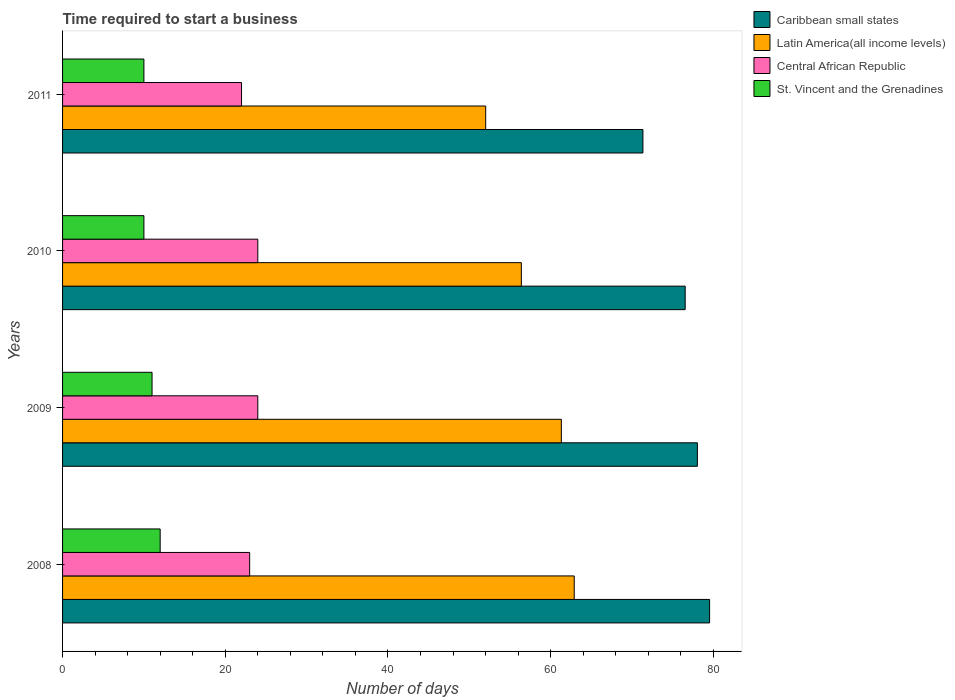How many groups of bars are there?
Your response must be concise. 4. In how many cases, is the number of bars for a given year not equal to the number of legend labels?
Make the answer very short. 0. In which year was the number of days required to start a business in Latin America(all income levels) maximum?
Your answer should be very brief. 2008. What is the total number of days required to start a business in Latin America(all income levels) in the graph?
Your answer should be very brief. 232.63. What is the difference between the number of days required to start a business in St. Vincent and the Grenadines in 2011 and the number of days required to start a business in Latin America(all income levels) in 2008?
Give a very brief answer. -52.9. What is the average number of days required to start a business in St. Vincent and the Grenadines per year?
Provide a short and direct response. 10.75. In the year 2009, what is the difference between the number of days required to start a business in Latin America(all income levels) and number of days required to start a business in Central African Republic?
Provide a short and direct response. 37.32. What is the ratio of the number of days required to start a business in Caribbean small states in 2010 to that in 2011?
Your answer should be compact. 1.07. Is the number of days required to start a business in St. Vincent and the Grenadines in 2009 less than that in 2010?
Provide a succinct answer. No. What is the difference between the highest and the lowest number of days required to start a business in Caribbean small states?
Provide a succinct answer. 8.2. In how many years, is the number of days required to start a business in Latin America(all income levels) greater than the average number of days required to start a business in Latin America(all income levels) taken over all years?
Provide a short and direct response. 2. Is the sum of the number of days required to start a business in Central African Republic in 2009 and 2011 greater than the maximum number of days required to start a business in Caribbean small states across all years?
Ensure brevity in your answer.  No. What does the 4th bar from the top in 2008 represents?
Your answer should be very brief. Caribbean small states. What does the 2nd bar from the bottom in 2008 represents?
Your answer should be very brief. Latin America(all income levels). How many bars are there?
Provide a short and direct response. 16. How many years are there in the graph?
Offer a very short reply. 4. What is the title of the graph?
Give a very brief answer. Time required to start a business. What is the label or title of the X-axis?
Make the answer very short. Number of days. What is the Number of days of Caribbean small states in 2008?
Provide a succinct answer. 79.54. What is the Number of days of Latin America(all income levels) in 2008?
Offer a very short reply. 62.9. What is the Number of days of Caribbean small states in 2009?
Your answer should be very brief. 78.04. What is the Number of days in Latin America(all income levels) in 2009?
Provide a short and direct response. 61.32. What is the Number of days of Caribbean small states in 2010?
Give a very brief answer. 76.54. What is the Number of days in Latin America(all income levels) in 2010?
Provide a succinct answer. 56.4. What is the Number of days of Central African Republic in 2010?
Keep it short and to the point. 24. What is the Number of days of Caribbean small states in 2011?
Give a very brief answer. 71.35. What is the Number of days of Latin America(all income levels) in 2011?
Your answer should be compact. 52.02. Across all years, what is the maximum Number of days of Caribbean small states?
Your response must be concise. 79.54. Across all years, what is the maximum Number of days of Latin America(all income levels)?
Provide a short and direct response. 62.9. Across all years, what is the minimum Number of days of Caribbean small states?
Provide a short and direct response. 71.35. Across all years, what is the minimum Number of days in Latin America(all income levels)?
Offer a very short reply. 52.02. Across all years, what is the minimum Number of days of Central African Republic?
Provide a succinct answer. 22. What is the total Number of days in Caribbean small states in the graph?
Keep it short and to the point. 305.47. What is the total Number of days of Latin America(all income levels) in the graph?
Make the answer very short. 232.63. What is the total Number of days of Central African Republic in the graph?
Provide a succinct answer. 93. What is the total Number of days of St. Vincent and the Grenadines in the graph?
Offer a very short reply. 43. What is the difference between the Number of days of Latin America(all income levels) in 2008 and that in 2009?
Your answer should be very brief. 1.58. What is the difference between the Number of days of Central African Republic in 2008 and that in 2009?
Keep it short and to the point. -1. What is the difference between the Number of days of St. Vincent and the Grenadines in 2008 and that in 2009?
Your answer should be compact. 1. What is the difference between the Number of days of Caribbean small states in 2008 and that in 2010?
Ensure brevity in your answer.  3. What is the difference between the Number of days in Latin America(all income levels) in 2008 and that in 2010?
Offer a terse response. 6.5. What is the difference between the Number of days of St. Vincent and the Grenadines in 2008 and that in 2010?
Make the answer very short. 2. What is the difference between the Number of days of Caribbean small states in 2008 and that in 2011?
Provide a succinct answer. 8.2. What is the difference between the Number of days of Latin America(all income levels) in 2008 and that in 2011?
Ensure brevity in your answer.  10.88. What is the difference between the Number of days of Latin America(all income levels) in 2009 and that in 2010?
Your response must be concise. 4.92. What is the difference between the Number of days in Central African Republic in 2009 and that in 2010?
Your response must be concise. 0. What is the difference between the Number of days in St. Vincent and the Grenadines in 2009 and that in 2010?
Your response must be concise. 1. What is the difference between the Number of days in Caribbean small states in 2009 and that in 2011?
Make the answer very short. 6.7. What is the difference between the Number of days in Latin America(all income levels) in 2009 and that in 2011?
Your response must be concise. 9.3. What is the difference between the Number of days of Central African Republic in 2009 and that in 2011?
Ensure brevity in your answer.  2. What is the difference between the Number of days in St. Vincent and the Grenadines in 2009 and that in 2011?
Ensure brevity in your answer.  1. What is the difference between the Number of days in Caribbean small states in 2010 and that in 2011?
Ensure brevity in your answer.  5.2. What is the difference between the Number of days in Latin America(all income levels) in 2010 and that in 2011?
Keep it short and to the point. 4.38. What is the difference between the Number of days in Central African Republic in 2010 and that in 2011?
Provide a short and direct response. 2. What is the difference between the Number of days in St. Vincent and the Grenadines in 2010 and that in 2011?
Offer a terse response. 0. What is the difference between the Number of days in Caribbean small states in 2008 and the Number of days in Latin America(all income levels) in 2009?
Ensure brevity in your answer.  18.23. What is the difference between the Number of days in Caribbean small states in 2008 and the Number of days in Central African Republic in 2009?
Keep it short and to the point. 55.54. What is the difference between the Number of days in Caribbean small states in 2008 and the Number of days in St. Vincent and the Grenadines in 2009?
Keep it short and to the point. 68.54. What is the difference between the Number of days of Latin America(all income levels) in 2008 and the Number of days of Central African Republic in 2009?
Keep it short and to the point. 38.9. What is the difference between the Number of days of Latin America(all income levels) in 2008 and the Number of days of St. Vincent and the Grenadines in 2009?
Your answer should be very brief. 51.9. What is the difference between the Number of days of Central African Republic in 2008 and the Number of days of St. Vincent and the Grenadines in 2009?
Your response must be concise. 12. What is the difference between the Number of days in Caribbean small states in 2008 and the Number of days in Latin America(all income levels) in 2010?
Ensure brevity in your answer.  23.14. What is the difference between the Number of days of Caribbean small states in 2008 and the Number of days of Central African Republic in 2010?
Your answer should be very brief. 55.54. What is the difference between the Number of days of Caribbean small states in 2008 and the Number of days of St. Vincent and the Grenadines in 2010?
Your answer should be compact. 69.54. What is the difference between the Number of days of Latin America(all income levels) in 2008 and the Number of days of Central African Republic in 2010?
Give a very brief answer. 38.9. What is the difference between the Number of days in Latin America(all income levels) in 2008 and the Number of days in St. Vincent and the Grenadines in 2010?
Offer a very short reply. 52.9. What is the difference between the Number of days in Caribbean small states in 2008 and the Number of days in Latin America(all income levels) in 2011?
Ensure brevity in your answer.  27.53. What is the difference between the Number of days in Caribbean small states in 2008 and the Number of days in Central African Republic in 2011?
Make the answer very short. 57.54. What is the difference between the Number of days in Caribbean small states in 2008 and the Number of days in St. Vincent and the Grenadines in 2011?
Make the answer very short. 69.54. What is the difference between the Number of days of Latin America(all income levels) in 2008 and the Number of days of Central African Republic in 2011?
Make the answer very short. 40.9. What is the difference between the Number of days of Latin America(all income levels) in 2008 and the Number of days of St. Vincent and the Grenadines in 2011?
Keep it short and to the point. 52.9. What is the difference between the Number of days of Central African Republic in 2008 and the Number of days of St. Vincent and the Grenadines in 2011?
Your response must be concise. 13. What is the difference between the Number of days of Caribbean small states in 2009 and the Number of days of Latin America(all income levels) in 2010?
Provide a short and direct response. 21.64. What is the difference between the Number of days of Caribbean small states in 2009 and the Number of days of Central African Republic in 2010?
Make the answer very short. 54.04. What is the difference between the Number of days of Caribbean small states in 2009 and the Number of days of St. Vincent and the Grenadines in 2010?
Make the answer very short. 68.04. What is the difference between the Number of days in Latin America(all income levels) in 2009 and the Number of days in Central African Republic in 2010?
Keep it short and to the point. 37.32. What is the difference between the Number of days in Latin America(all income levels) in 2009 and the Number of days in St. Vincent and the Grenadines in 2010?
Provide a succinct answer. 51.32. What is the difference between the Number of days in Central African Republic in 2009 and the Number of days in St. Vincent and the Grenadines in 2010?
Your answer should be very brief. 14. What is the difference between the Number of days of Caribbean small states in 2009 and the Number of days of Latin America(all income levels) in 2011?
Offer a terse response. 26.03. What is the difference between the Number of days in Caribbean small states in 2009 and the Number of days in Central African Republic in 2011?
Provide a succinct answer. 56.04. What is the difference between the Number of days in Caribbean small states in 2009 and the Number of days in St. Vincent and the Grenadines in 2011?
Your response must be concise. 68.04. What is the difference between the Number of days in Latin America(all income levels) in 2009 and the Number of days in Central African Republic in 2011?
Give a very brief answer. 39.32. What is the difference between the Number of days in Latin America(all income levels) in 2009 and the Number of days in St. Vincent and the Grenadines in 2011?
Make the answer very short. 51.32. What is the difference between the Number of days in Central African Republic in 2009 and the Number of days in St. Vincent and the Grenadines in 2011?
Provide a short and direct response. 14. What is the difference between the Number of days of Caribbean small states in 2010 and the Number of days of Latin America(all income levels) in 2011?
Keep it short and to the point. 24.53. What is the difference between the Number of days in Caribbean small states in 2010 and the Number of days in Central African Republic in 2011?
Your answer should be very brief. 54.54. What is the difference between the Number of days in Caribbean small states in 2010 and the Number of days in St. Vincent and the Grenadines in 2011?
Your answer should be very brief. 66.54. What is the difference between the Number of days of Latin America(all income levels) in 2010 and the Number of days of Central African Republic in 2011?
Your answer should be very brief. 34.4. What is the difference between the Number of days in Latin America(all income levels) in 2010 and the Number of days in St. Vincent and the Grenadines in 2011?
Your answer should be compact. 46.4. What is the average Number of days of Caribbean small states per year?
Ensure brevity in your answer.  76.37. What is the average Number of days of Latin America(all income levels) per year?
Make the answer very short. 58.16. What is the average Number of days in Central African Republic per year?
Your response must be concise. 23.25. What is the average Number of days in St. Vincent and the Grenadines per year?
Keep it short and to the point. 10.75. In the year 2008, what is the difference between the Number of days of Caribbean small states and Number of days of Latin America(all income levels)?
Provide a short and direct response. 16.64. In the year 2008, what is the difference between the Number of days in Caribbean small states and Number of days in Central African Republic?
Offer a very short reply. 56.54. In the year 2008, what is the difference between the Number of days of Caribbean small states and Number of days of St. Vincent and the Grenadines?
Offer a terse response. 67.54. In the year 2008, what is the difference between the Number of days of Latin America(all income levels) and Number of days of Central African Republic?
Make the answer very short. 39.9. In the year 2008, what is the difference between the Number of days in Latin America(all income levels) and Number of days in St. Vincent and the Grenadines?
Make the answer very short. 50.9. In the year 2009, what is the difference between the Number of days in Caribbean small states and Number of days in Latin America(all income levels)?
Keep it short and to the point. 16.73. In the year 2009, what is the difference between the Number of days in Caribbean small states and Number of days in Central African Republic?
Your answer should be compact. 54.04. In the year 2009, what is the difference between the Number of days in Caribbean small states and Number of days in St. Vincent and the Grenadines?
Give a very brief answer. 67.04. In the year 2009, what is the difference between the Number of days of Latin America(all income levels) and Number of days of Central African Republic?
Provide a short and direct response. 37.32. In the year 2009, what is the difference between the Number of days of Latin America(all income levels) and Number of days of St. Vincent and the Grenadines?
Your answer should be very brief. 50.32. In the year 2010, what is the difference between the Number of days of Caribbean small states and Number of days of Latin America(all income levels)?
Provide a short and direct response. 20.14. In the year 2010, what is the difference between the Number of days of Caribbean small states and Number of days of Central African Republic?
Ensure brevity in your answer.  52.54. In the year 2010, what is the difference between the Number of days in Caribbean small states and Number of days in St. Vincent and the Grenadines?
Keep it short and to the point. 66.54. In the year 2010, what is the difference between the Number of days of Latin America(all income levels) and Number of days of Central African Republic?
Make the answer very short. 32.4. In the year 2010, what is the difference between the Number of days in Latin America(all income levels) and Number of days in St. Vincent and the Grenadines?
Offer a terse response. 46.4. In the year 2011, what is the difference between the Number of days of Caribbean small states and Number of days of Latin America(all income levels)?
Ensure brevity in your answer.  19.33. In the year 2011, what is the difference between the Number of days of Caribbean small states and Number of days of Central African Republic?
Make the answer very short. 49.35. In the year 2011, what is the difference between the Number of days in Caribbean small states and Number of days in St. Vincent and the Grenadines?
Offer a terse response. 61.35. In the year 2011, what is the difference between the Number of days in Latin America(all income levels) and Number of days in Central African Republic?
Give a very brief answer. 30.02. In the year 2011, what is the difference between the Number of days in Latin America(all income levels) and Number of days in St. Vincent and the Grenadines?
Make the answer very short. 42.02. What is the ratio of the Number of days of Caribbean small states in 2008 to that in 2009?
Provide a succinct answer. 1.02. What is the ratio of the Number of days of Latin America(all income levels) in 2008 to that in 2009?
Your answer should be compact. 1.03. What is the ratio of the Number of days in St. Vincent and the Grenadines in 2008 to that in 2009?
Make the answer very short. 1.09. What is the ratio of the Number of days in Caribbean small states in 2008 to that in 2010?
Provide a succinct answer. 1.04. What is the ratio of the Number of days of Latin America(all income levels) in 2008 to that in 2010?
Your response must be concise. 1.12. What is the ratio of the Number of days in Central African Republic in 2008 to that in 2010?
Your answer should be very brief. 0.96. What is the ratio of the Number of days of St. Vincent and the Grenadines in 2008 to that in 2010?
Make the answer very short. 1.2. What is the ratio of the Number of days of Caribbean small states in 2008 to that in 2011?
Ensure brevity in your answer.  1.11. What is the ratio of the Number of days in Latin America(all income levels) in 2008 to that in 2011?
Make the answer very short. 1.21. What is the ratio of the Number of days of Central African Republic in 2008 to that in 2011?
Ensure brevity in your answer.  1.05. What is the ratio of the Number of days in St. Vincent and the Grenadines in 2008 to that in 2011?
Provide a succinct answer. 1.2. What is the ratio of the Number of days in Caribbean small states in 2009 to that in 2010?
Provide a succinct answer. 1.02. What is the ratio of the Number of days of Latin America(all income levels) in 2009 to that in 2010?
Your answer should be compact. 1.09. What is the ratio of the Number of days in Central African Republic in 2009 to that in 2010?
Make the answer very short. 1. What is the ratio of the Number of days of St. Vincent and the Grenadines in 2009 to that in 2010?
Your answer should be compact. 1.1. What is the ratio of the Number of days in Caribbean small states in 2009 to that in 2011?
Provide a succinct answer. 1.09. What is the ratio of the Number of days of Latin America(all income levels) in 2009 to that in 2011?
Offer a very short reply. 1.18. What is the ratio of the Number of days in Central African Republic in 2009 to that in 2011?
Offer a terse response. 1.09. What is the ratio of the Number of days in St. Vincent and the Grenadines in 2009 to that in 2011?
Your answer should be very brief. 1.1. What is the ratio of the Number of days in Caribbean small states in 2010 to that in 2011?
Make the answer very short. 1.07. What is the ratio of the Number of days of Latin America(all income levels) in 2010 to that in 2011?
Make the answer very short. 1.08. What is the difference between the highest and the second highest Number of days in Latin America(all income levels)?
Your answer should be very brief. 1.58. What is the difference between the highest and the lowest Number of days of Caribbean small states?
Your response must be concise. 8.2. What is the difference between the highest and the lowest Number of days in Latin America(all income levels)?
Your answer should be very brief. 10.88. 